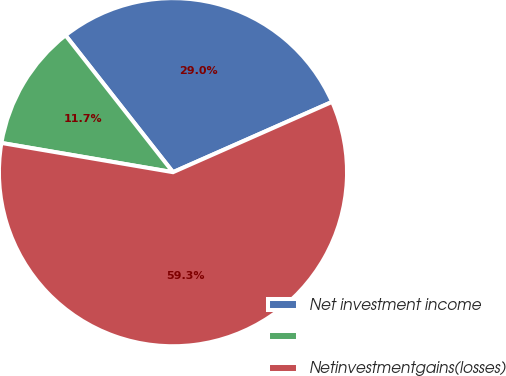<chart> <loc_0><loc_0><loc_500><loc_500><pie_chart><fcel>Net investment income<fcel>Unnamed: 1<fcel>Netinvestmentgains(losses)<nl><fcel>28.97%<fcel>11.72%<fcel>59.31%<nl></chart> 